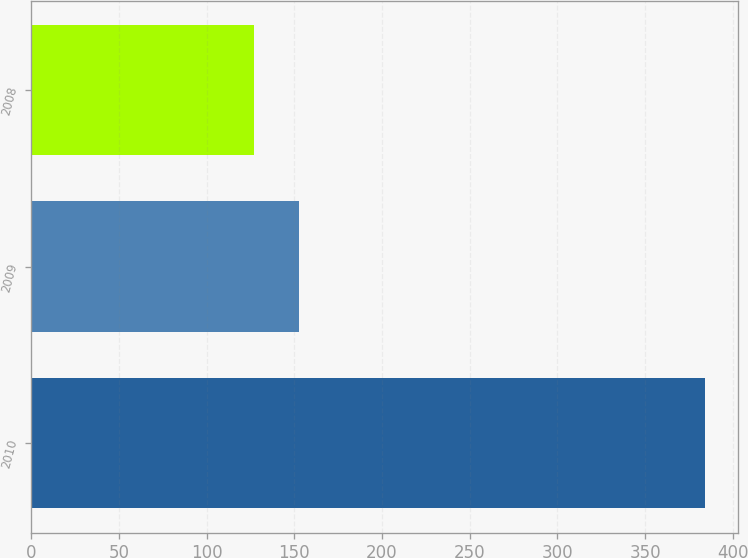Convert chart. <chart><loc_0><loc_0><loc_500><loc_500><bar_chart><fcel>2010<fcel>2009<fcel>2008<nl><fcel>384<fcel>152.7<fcel>127<nl></chart> 